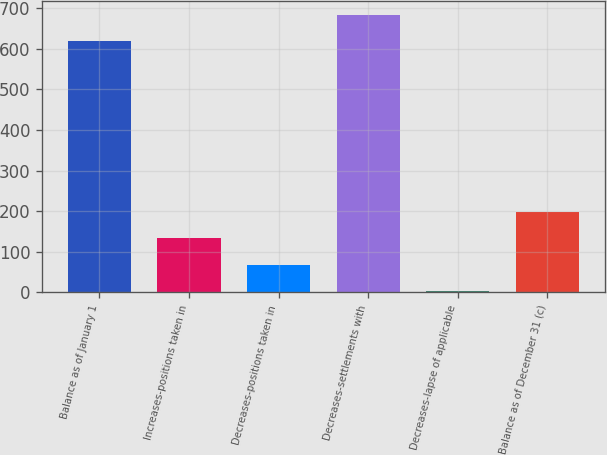Convert chart to OTSL. <chart><loc_0><loc_0><loc_500><loc_500><bar_chart><fcel>Balance as of January 1<fcel>Increases-positions taken in<fcel>Decreases-positions taken in<fcel>Decreases-settlements with<fcel>Decreases-lapse of applicable<fcel>Balance as of December 31 (c)<nl><fcel>618.7<fcel>132.66<fcel>67.88<fcel>683.48<fcel>3.1<fcel>197.44<nl></chart> 